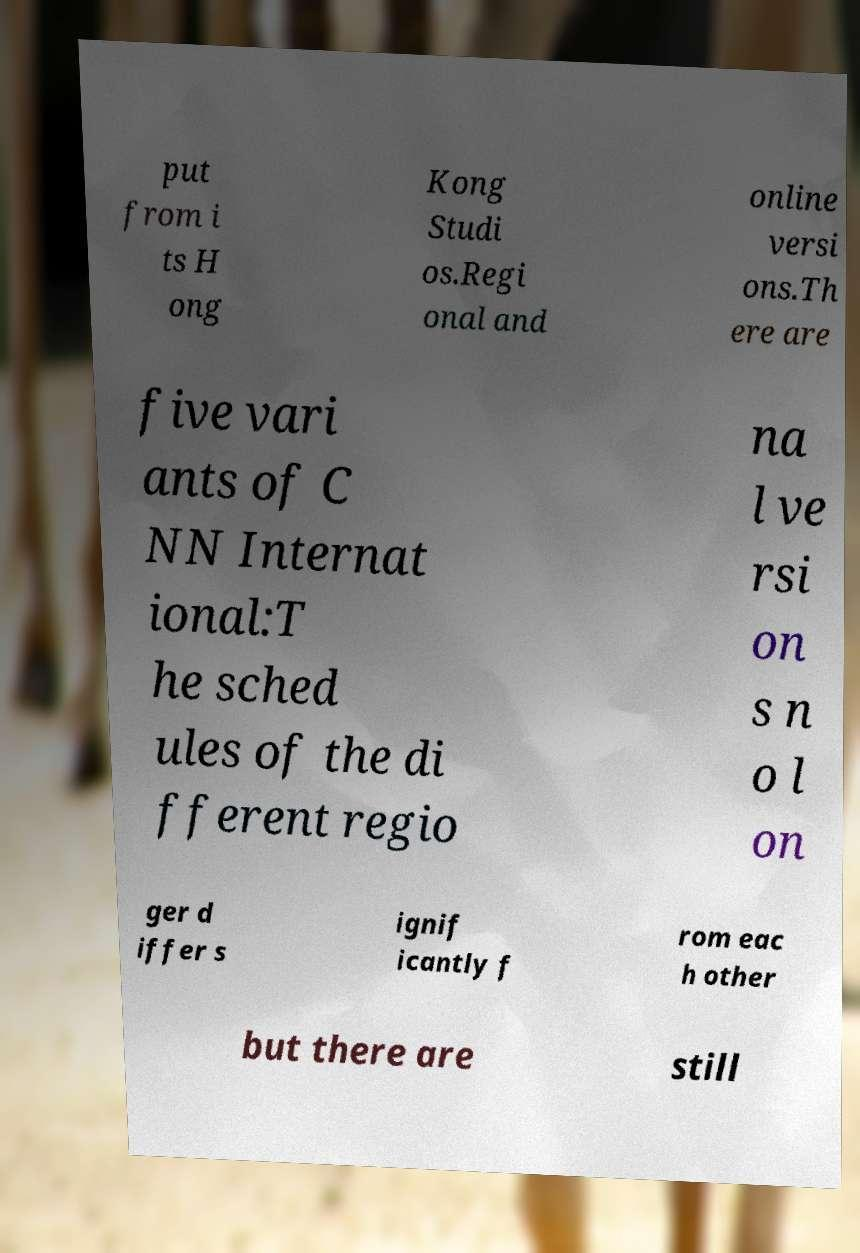Could you assist in decoding the text presented in this image and type it out clearly? put from i ts H ong Kong Studi os.Regi onal and online versi ons.Th ere are five vari ants of C NN Internat ional:T he sched ules of the di fferent regio na l ve rsi on s n o l on ger d iffer s ignif icantly f rom eac h other but there are still 